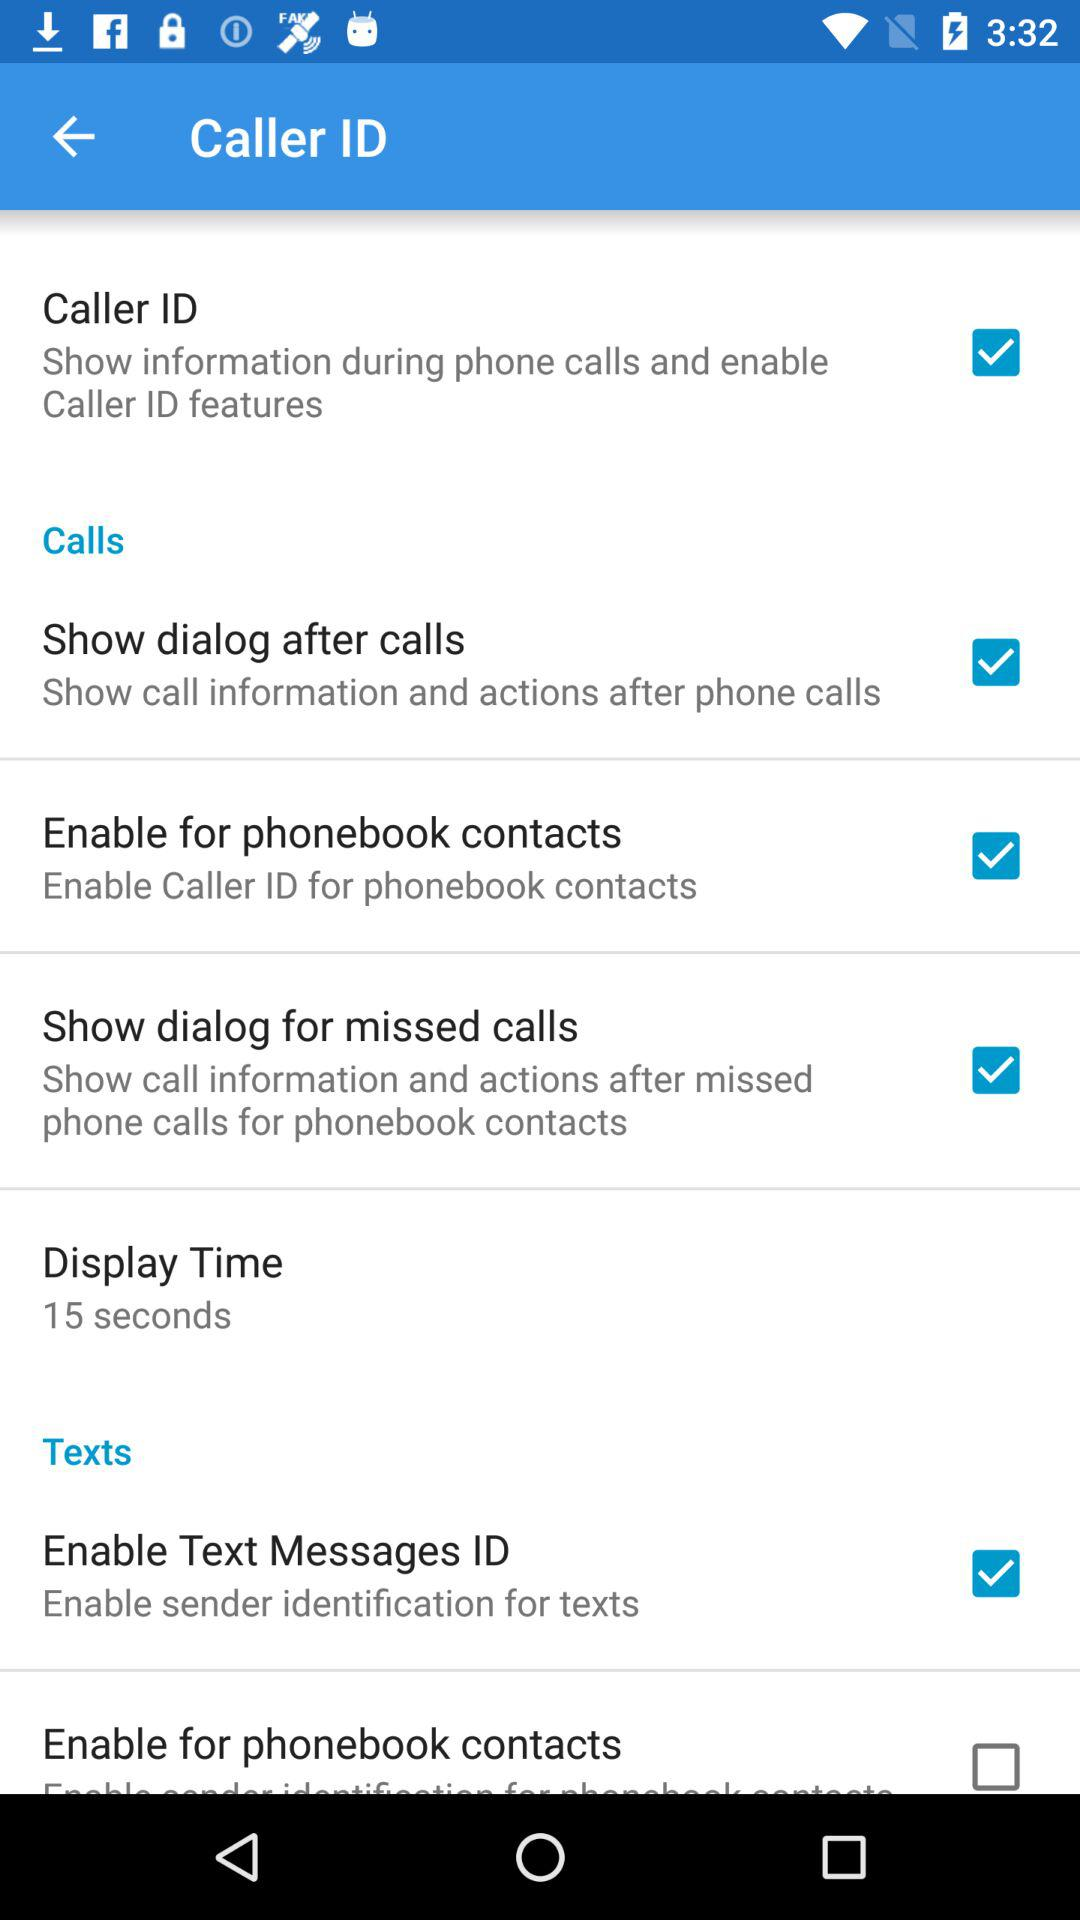What is the status of "Caller ID"? The status is "on". 